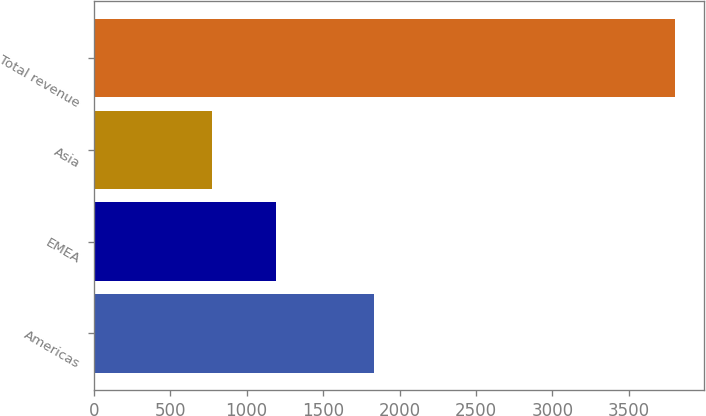Convert chart to OTSL. <chart><loc_0><loc_0><loc_500><loc_500><bar_chart><fcel>Americas<fcel>EMEA<fcel>Asia<fcel>Total revenue<nl><fcel>1835.3<fcel>1191.9<fcel>772.8<fcel>3800<nl></chart> 